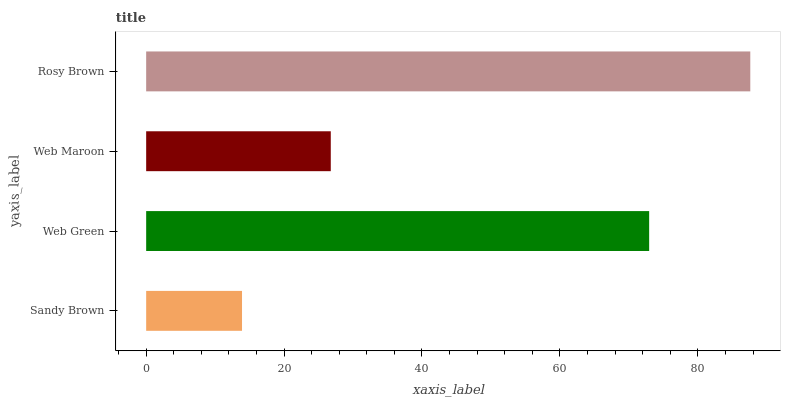Is Sandy Brown the minimum?
Answer yes or no. Yes. Is Rosy Brown the maximum?
Answer yes or no. Yes. Is Web Green the minimum?
Answer yes or no. No. Is Web Green the maximum?
Answer yes or no. No. Is Web Green greater than Sandy Brown?
Answer yes or no. Yes. Is Sandy Brown less than Web Green?
Answer yes or no. Yes. Is Sandy Brown greater than Web Green?
Answer yes or no. No. Is Web Green less than Sandy Brown?
Answer yes or no. No. Is Web Green the high median?
Answer yes or no. Yes. Is Web Maroon the low median?
Answer yes or no. Yes. Is Sandy Brown the high median?
Answer yes or no. No. Is Rosy Brown the low median?
Answer yes or no. No. 